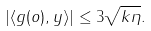Convert formula to latex. <formula><loc_0><loc_0><loc_500><loc_500>| \langle g ( o ) , y \rangle | \leq 3 \sqrt { k \eta } .</formula> 